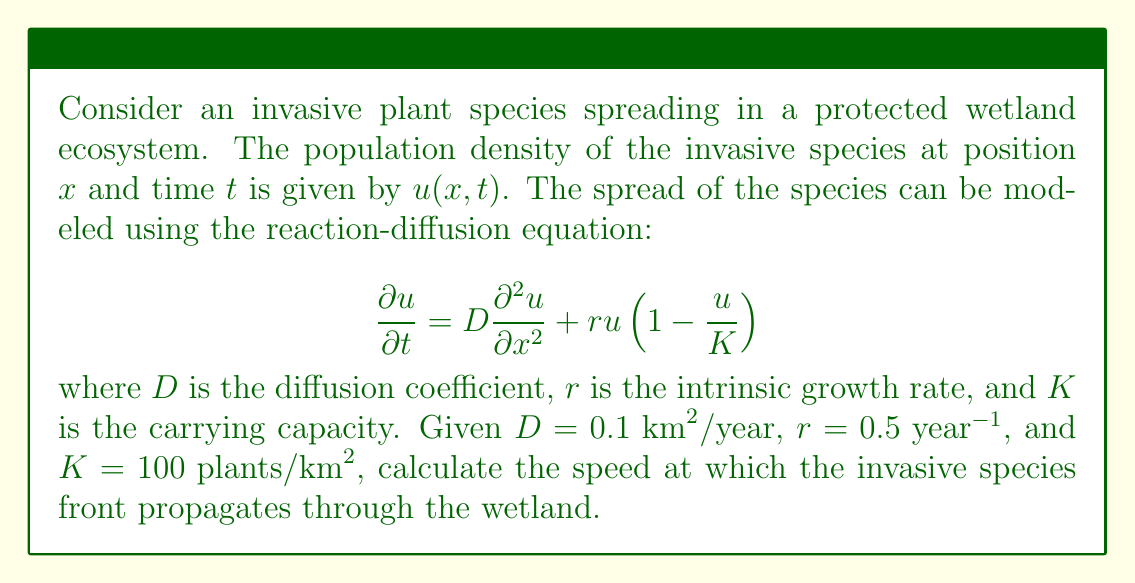Solve this math problem. To solve this problem, we need to understand the concept of traveling wave solutions in reaction-diffusion equations. For the given Fisher-KPP (Kolmogorov-Petrovsky-Piskunov) equation, the speed of propagation of the invasive species front can be determined using the following steps:

1) The minimum speed of propagation for a traveling wave solution in a Fisher-KPP equation is given by:

   $$c_{min} = 2\sqrt{rD}$$

   where $c_{min}$ is the minimum wave speed, $r$ is the intrinsic growth rate, and $D$ is the diffusion coefficient.

2) We are given:
   $D = 0.1 \text{ km}^2/\text{year}$
   $r = 0.5 \text{ year}^{-1}$

3) Substituting these values into the equation:

   $$c_{min} = 2\sqrt{(0.5 \text{ year}^{-1})(0.1 \text{ km}^2/\text{year})}$$

4) Simplify under the square root:

   $$c_{min} = 2\sqrt{0.05 \text{ km}^2/\text{year}^2}$$

5) Calculate the square root:

   $$c_{min} = 2(0.2236 \text{ km}/\text{year})$$

6) Perform the final multiplication:

   $$c_{min} = 0.4472 \text{ km}/\text{year}$$

This result represents the speed at which the invasive species front will propagate through the wetland ecosystem.
Answer: The speed at which the invasive species front propagates through the wetland is approximately $0.4472 \text{ km}/\text{year}$. 